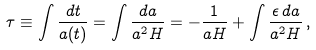Convert formula to latex. <formula><loc_0><loc_0><loc_500><loc_500>\tau \equiv \int \frac { d t } { a ( t ) } = \int \frac { d a } { a ^ { 2 } H } = - \frac { 1 } { a H } + \int \frac { \epsilon \, d a } { a ^ { 2 } H } \, ,</formula> 